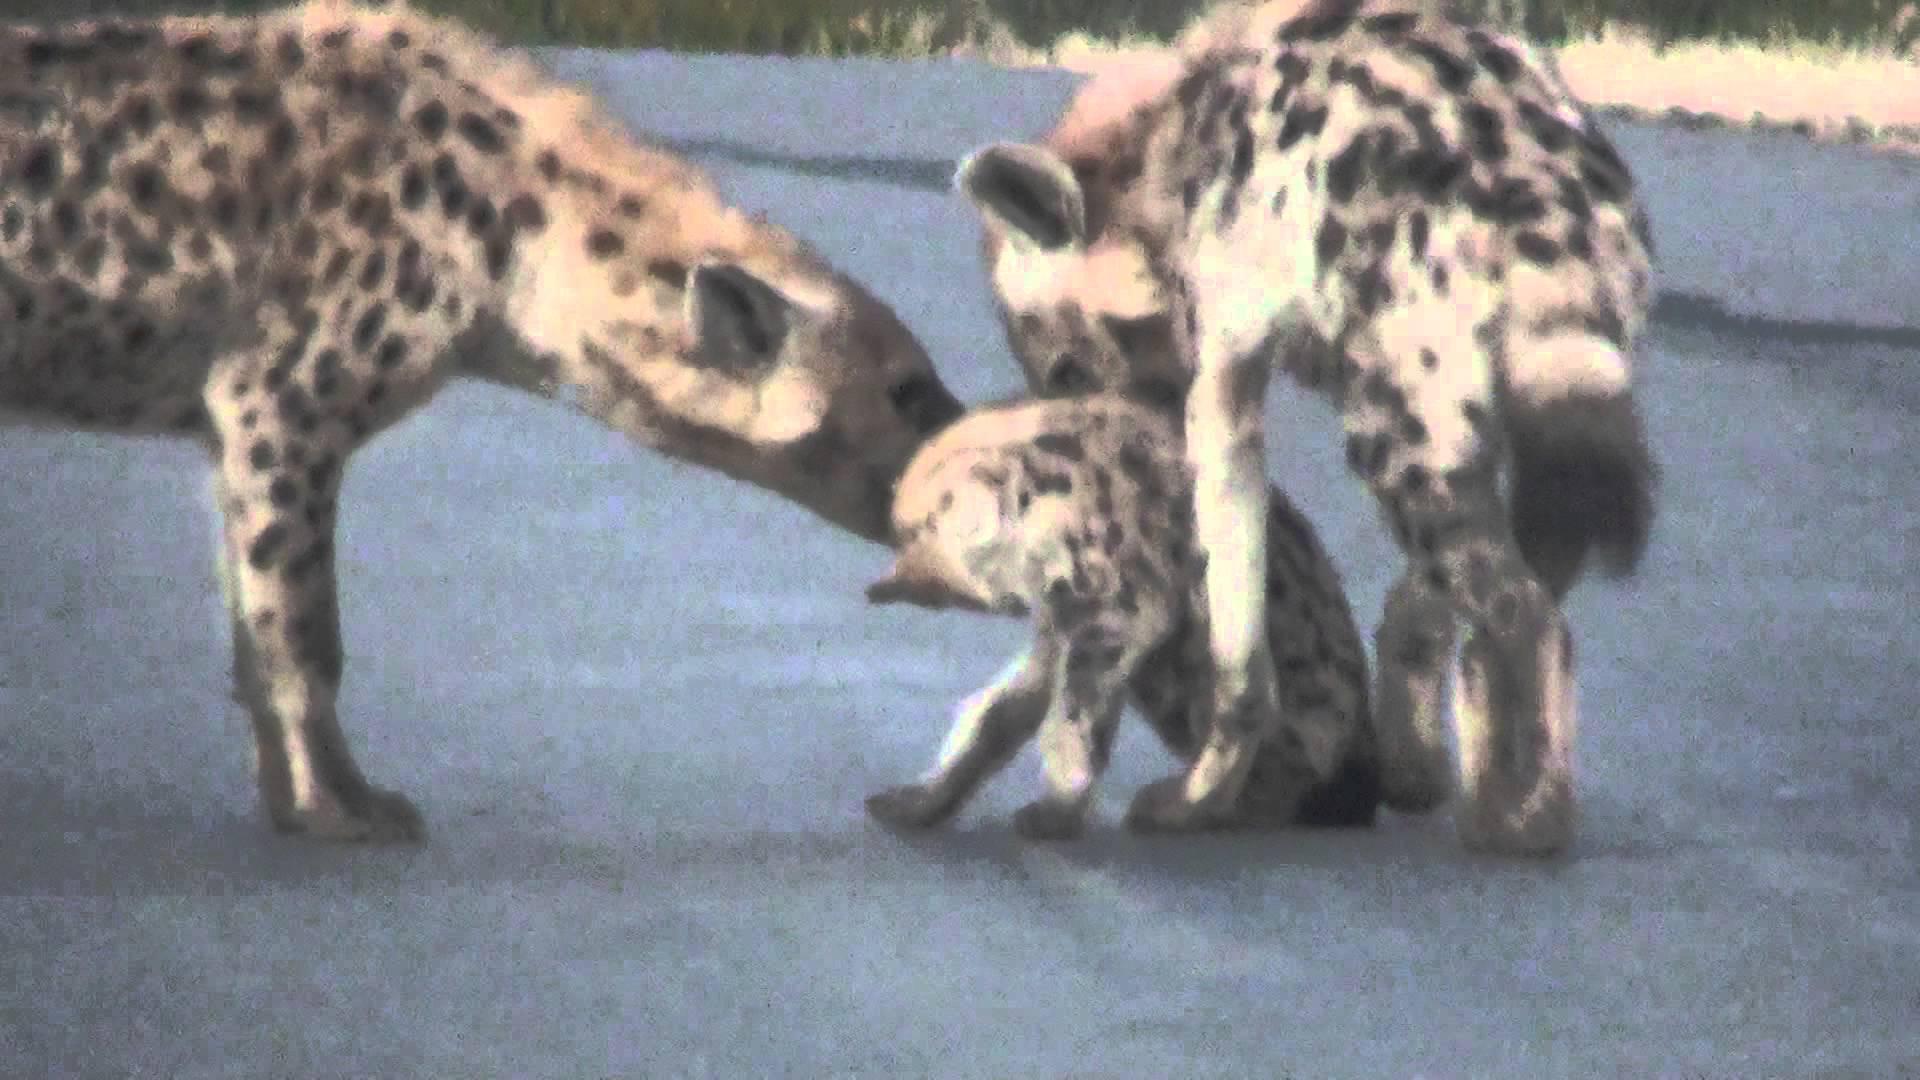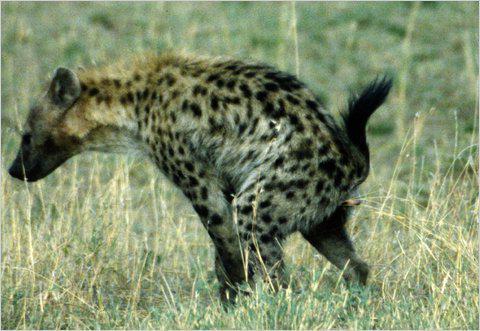The first image is the image on the left, the second image is the image on the right. Considering the images on both sides, is "There are exactly four hyenas." valid? Answer yes or no. Yes. The first image is the image on the left, the second image is the image on the right. Analyze the images presented: Is the assertion "The right image has two hyenas laying on the ground" valid? Answer yes or no. No. 